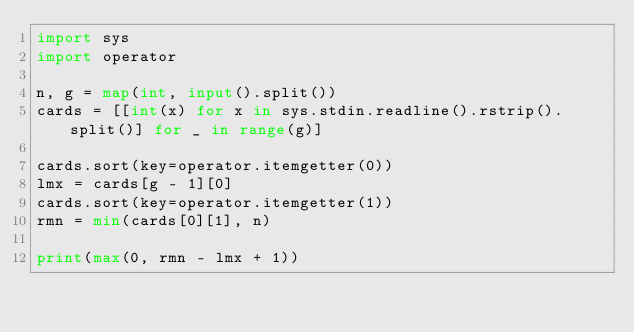<code> <loc_0><loc_0><loc_500><loc_500><_Python_>import sys
import operator

n, g = map(int, input().split())
cards = [[int(x) for x in sys.stdin.readline().rstrip().split()] for _ in range(g)]

cards.sort(key=operator.itemgetter(0))
lmx = cards[g - 1][0]
cards.sort(key=operator.itemgetter(1))
rmn = min(cards[0][1], n)

print(max(0, rmn - lmx + 1))
</code> 